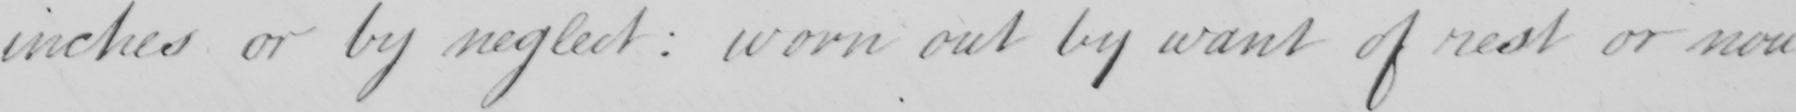Can you tell me what this handwritten text says? inches or by neglect  :  worn out by want of rest or nou- 